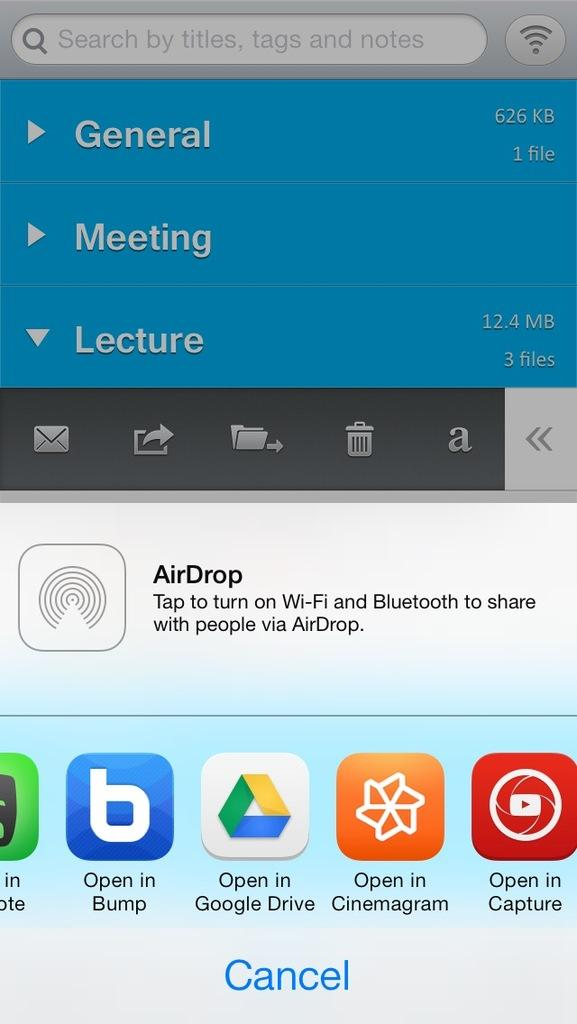<image>
Describe the image concisely. A smart phone screen open to a screen with AirDrop on it. 